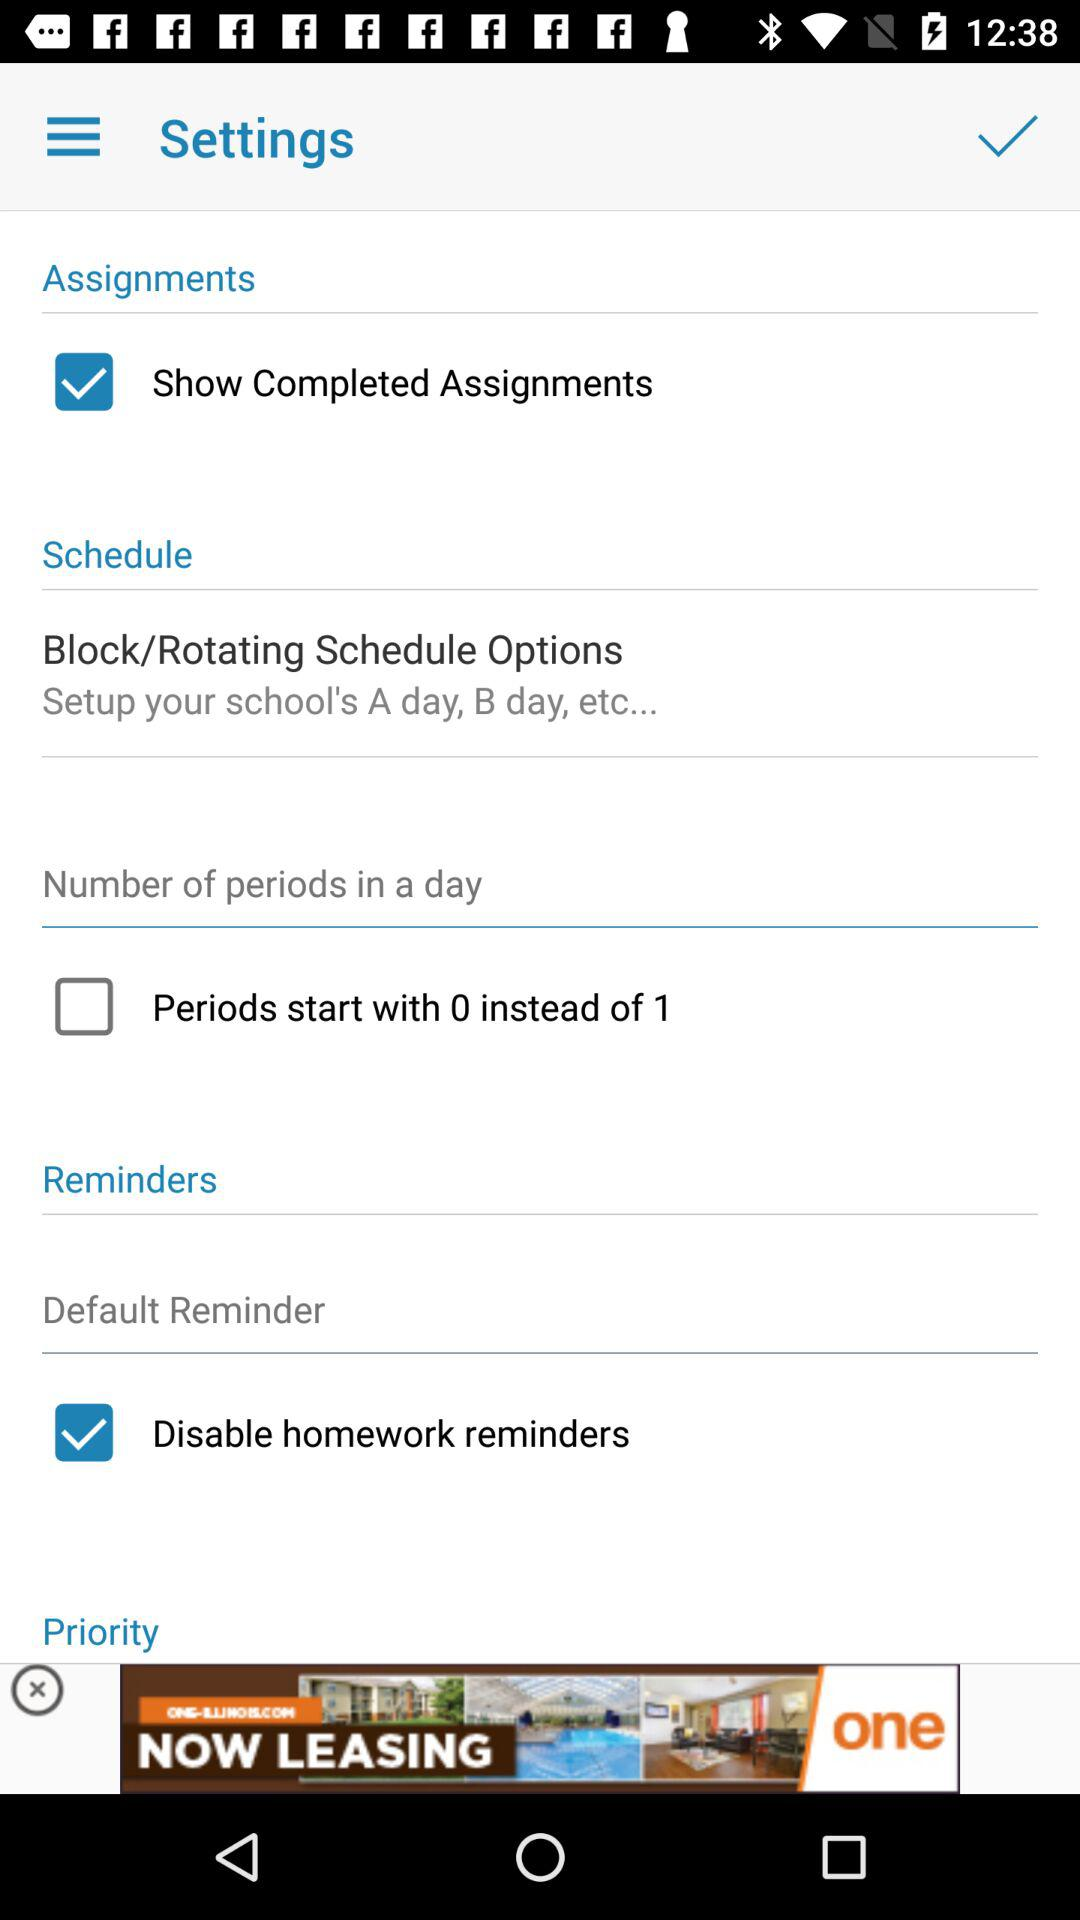What is the status of the "Periods start with 0 instead of 1"? The status of the "Periods start with 0 instead of 1" is "off". 